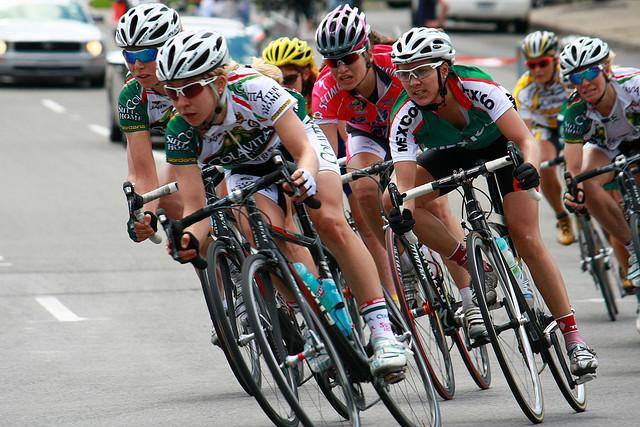What are the women participating in? cycling 